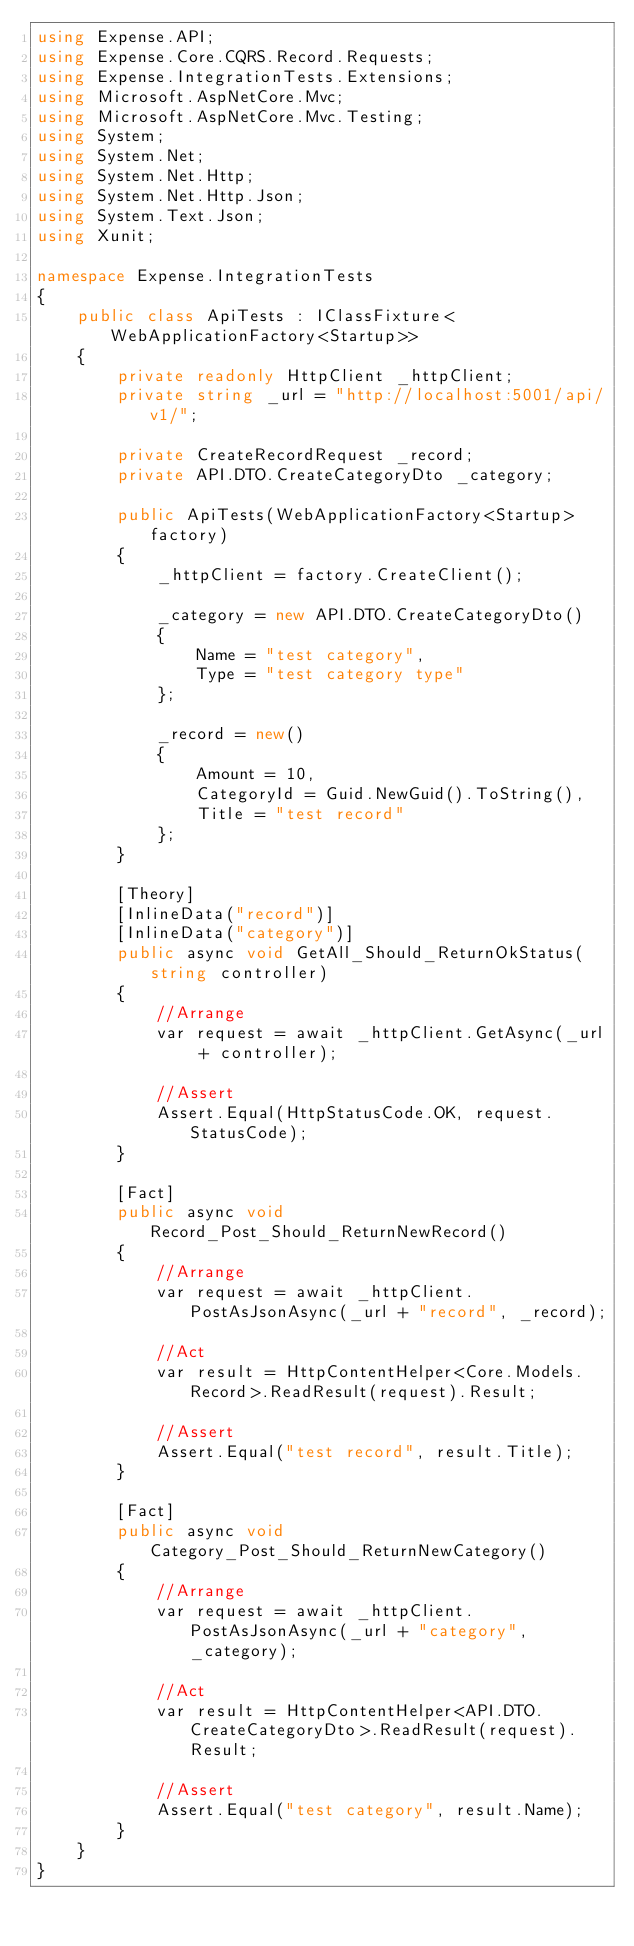<code> <loc_0><loc_0><loc_500><loc_500><_C#_>using Expense.API;
using Expense.Core.CQRS.Record.Requests;
using Expense.IntegrationTests.Extensions;
using Microsoft.AspNetCore.Mvc;
using Microsoft.AspNetCore.Mvc.Testing;
using System;
using System.Net;
using System.Net.Http;
using System.Net.Http.Json;
using System.Text.Json;
using Xunit;

namespace Expense.IntegrationTests
{
    public class ApiTests : IClassFixture<WebApplicationFactory<Startup>>
    {
        private readonly HttpClient _httpClient;
        private string _url = "http://localhost:5001/api/v1/";

        private CreateRecordRequest _record;
        private API.DTO.CreateCategoryDto _category;

        public ApiTests(WebApplicationFactory<Startup> factory)
        {
            _httpClient = factory.CreateClient();

            _category = new API.DTO.CreateCategoryDto()
            {
                Name = "test category",
                Type = "test category type"
            };

            _record = new()
            {
                Amount = 10,
                CategoryId = Guid.NewGuid().ToString(),
                Title = "test record"
            };
        }

        [Theory]
        [InlineData("record")]
        [InlineData("category")]
        public async void GetAll_Should_ReturnOkStatus(string controller)
        {
            //Arrange
            var request = await _httpClient.GetAsync(_url + controller);

            //Assert
            Assert.Equal(HttpStatusCode.OK, request.StatusCode);
        }

        [Fact]
        public async void Record_Post_Should_ReturnNewRecord()
        {
            //Arrange
            var request = await _httpClient.PostAsJsonAsync(_url + "record", _record);

            //Act
            var result = HttpContentHelper<Core.Models.Record>.ReadResult(request).Result;

            //Assert
            Assert.Equal("test record", result.Title);
        }

        [Fact]
        public async void Category_Post_Should_ReturnNewCategory()
        {
            //Arrange
            var request = await _httpClient.PostAsJsonAsync(_url + "category", _category);

            //Act
            var result = HttpContentHelper<API.DTO.CreateCategoryDto>.ReadResult(request).Result;

            //Assert
            Assert.Equal("test category", result.Name);
        }
    }
}
</code> 